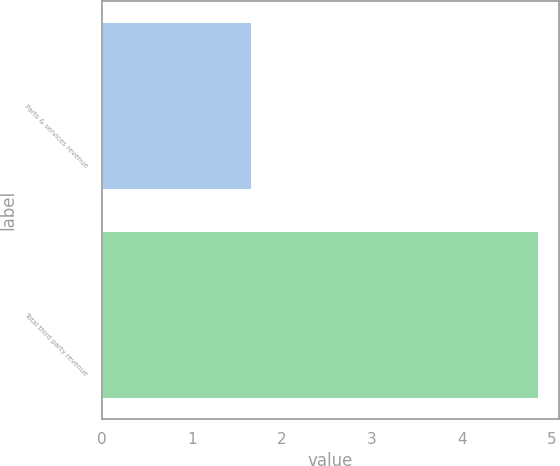<chart> <loc_0><loc_0><loc_500><loc_500><bar_chart><fcel>Parts & services revenue<fcel>Total third party revenue<nl><fcel>1.66<fcel>4.84<nl></chart> 